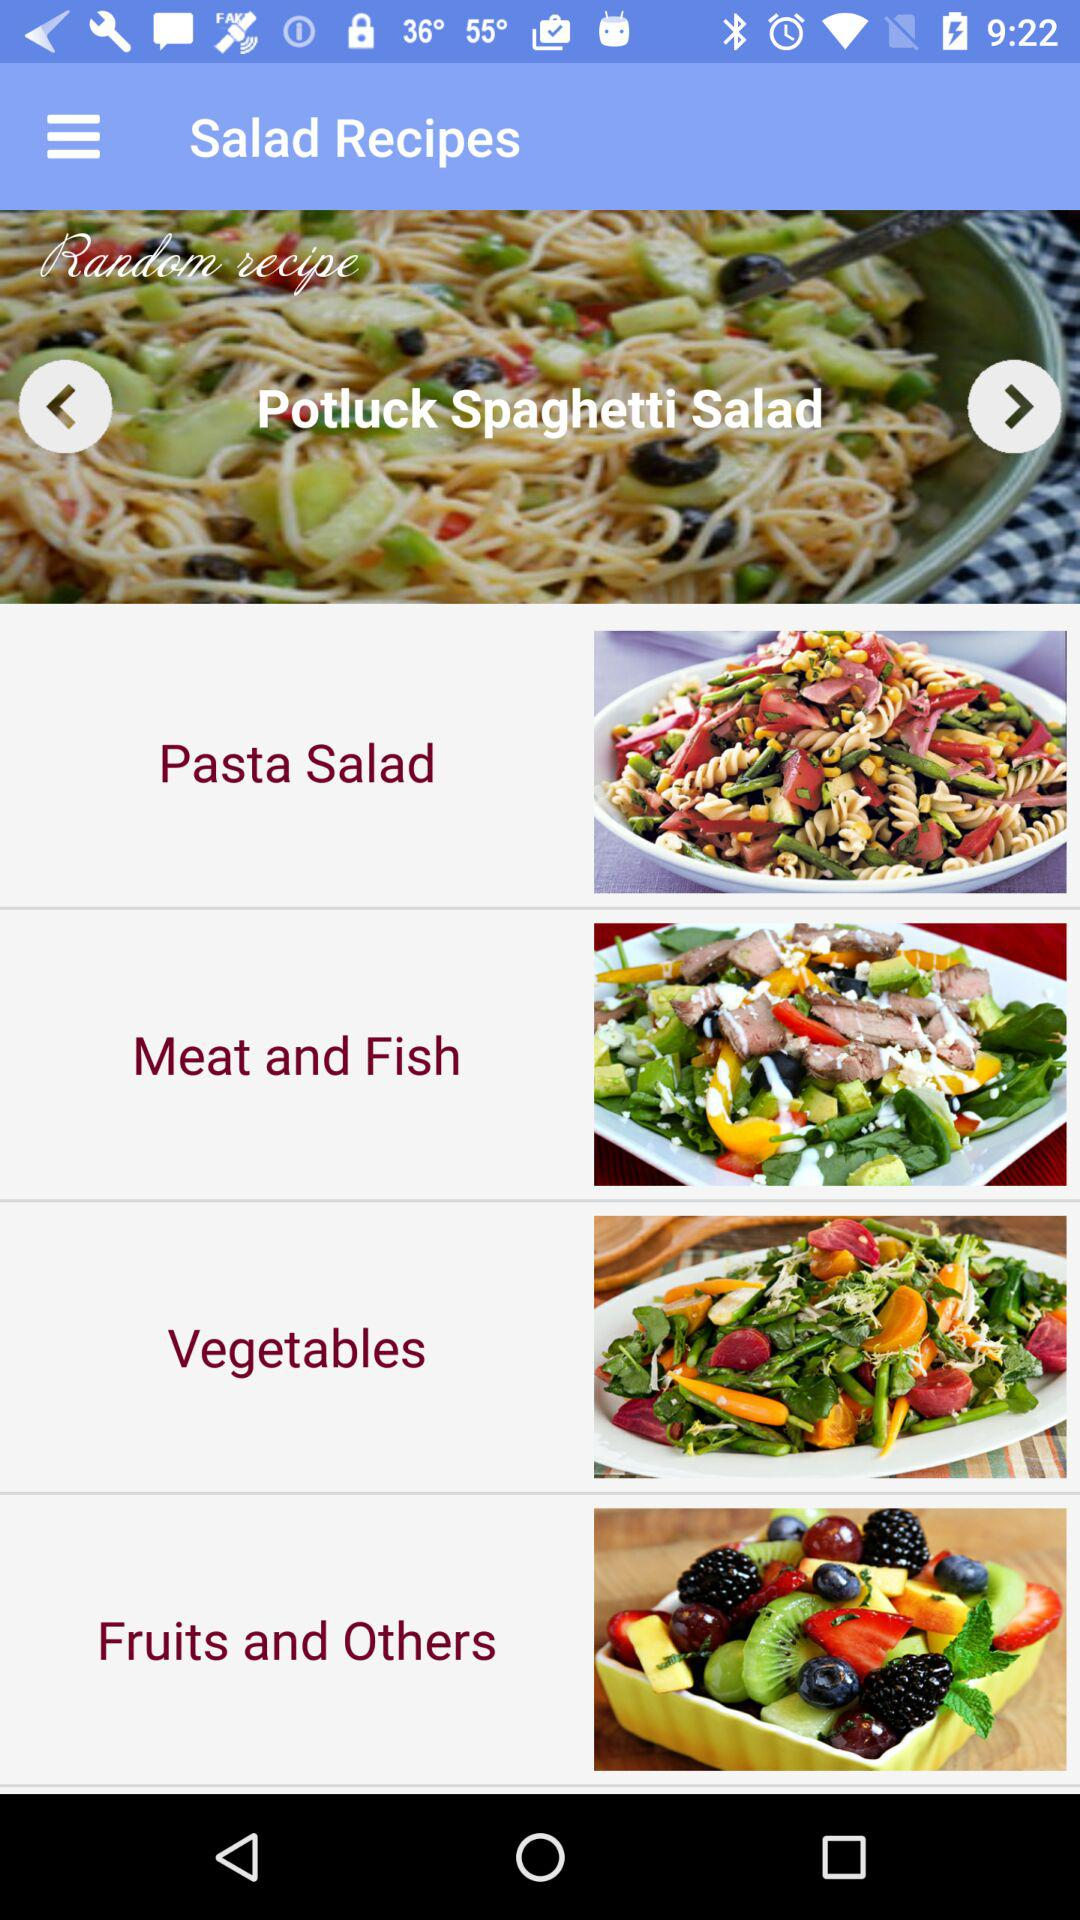What is the name of random recipe? The name of random recipe is "Potluck Spaghetti Salad". 